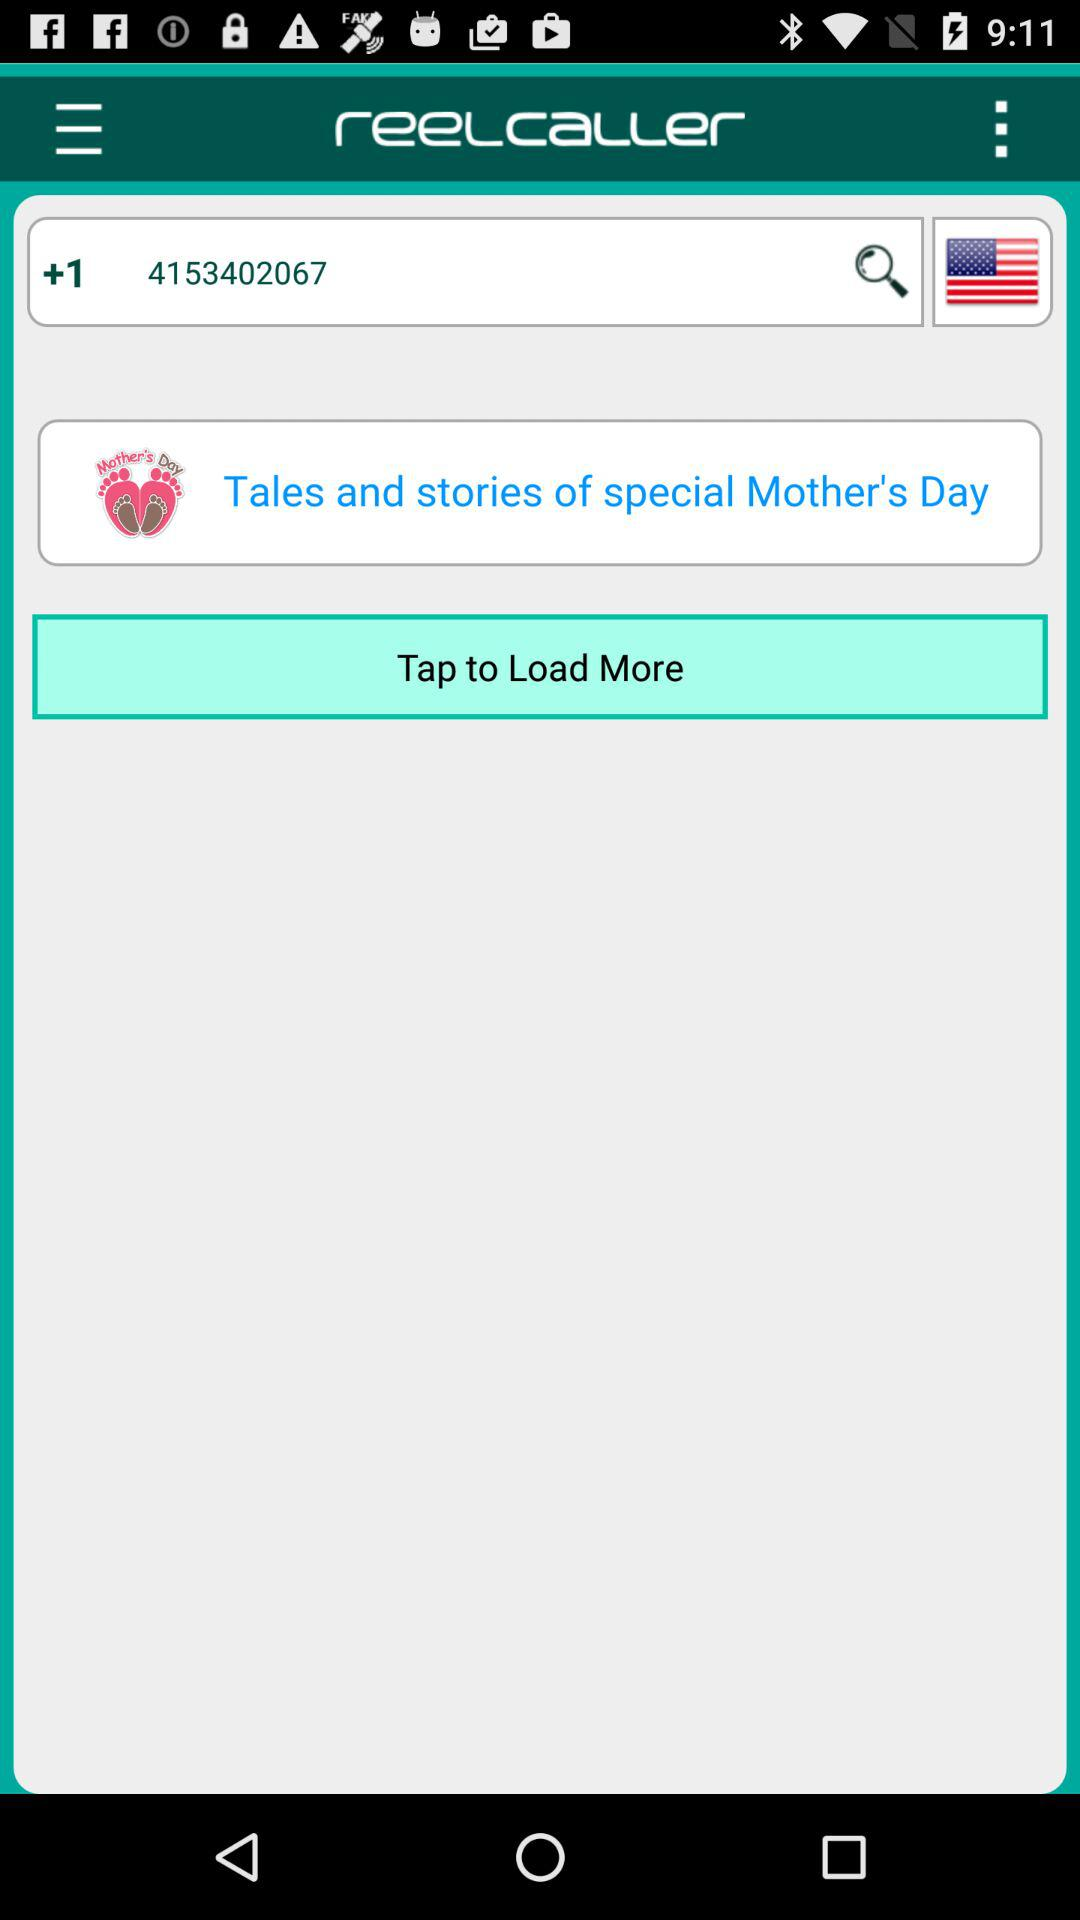What is the application name? The application name is "reelcaller". 